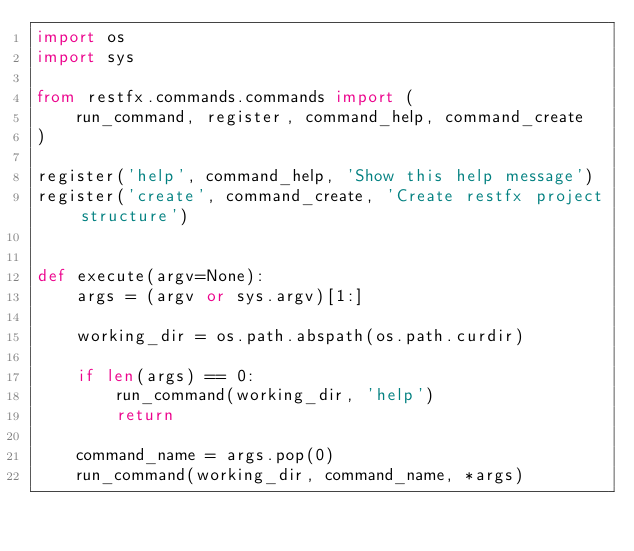Convert code to text. <code><loc_0><loc_0><loc_500><loc_500><_Python_>import os
import sys

from restfx.commands.commands import (
    run_command, register, command_help, command_create
)

register('help', command_help, 'Show this help message')
register('create', command_create, 'Create restfx project structure')


def execute(argv=None):
    args = (argv or sys.argv)[1:]

    working_dir = os.path.abspath(os.path.curdir)

    if len(args) == 0:
        run_command(working_dir, 'help')
        return

    command_name = args.pop(0)
    run_command(working_dir, command_name, *args)
</code> 